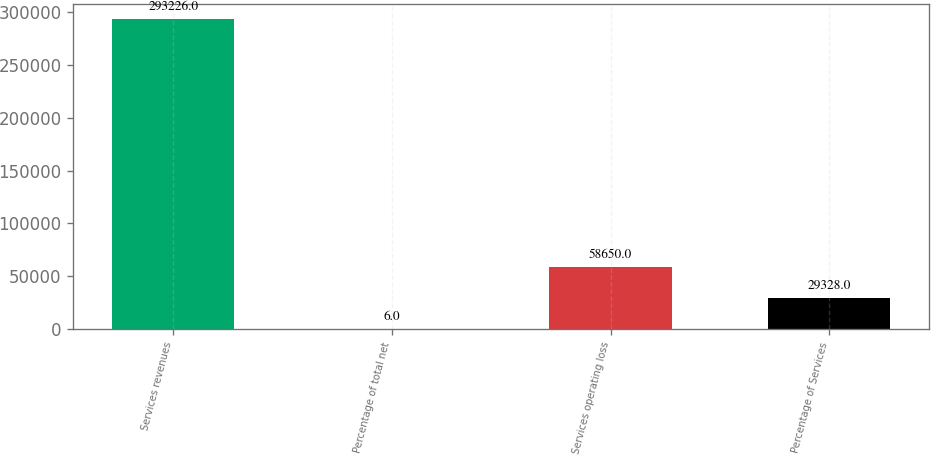Convert chart to OTSL. <chart><loc_0><loc_0><loc_500><loc_500><bar_chart><fcel>Services revenues<fcel>Percentage of total net<fcel>Services operating loss<fcel>Percentage of Services<nl><fcel>293226<fcel>6<fcel>58650<fcel>29328<nl></chart> 